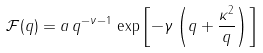<formula> <loc_0><loc_0><loc_500><loc_500>\mathcal { F } ( q ) = a \, q ^ { - \nu - 1 } \, \exp \left [ - \gamma \left ( q + \frac { \kappa ^ { 2 } } { q } \right ) \right ]</formula> 